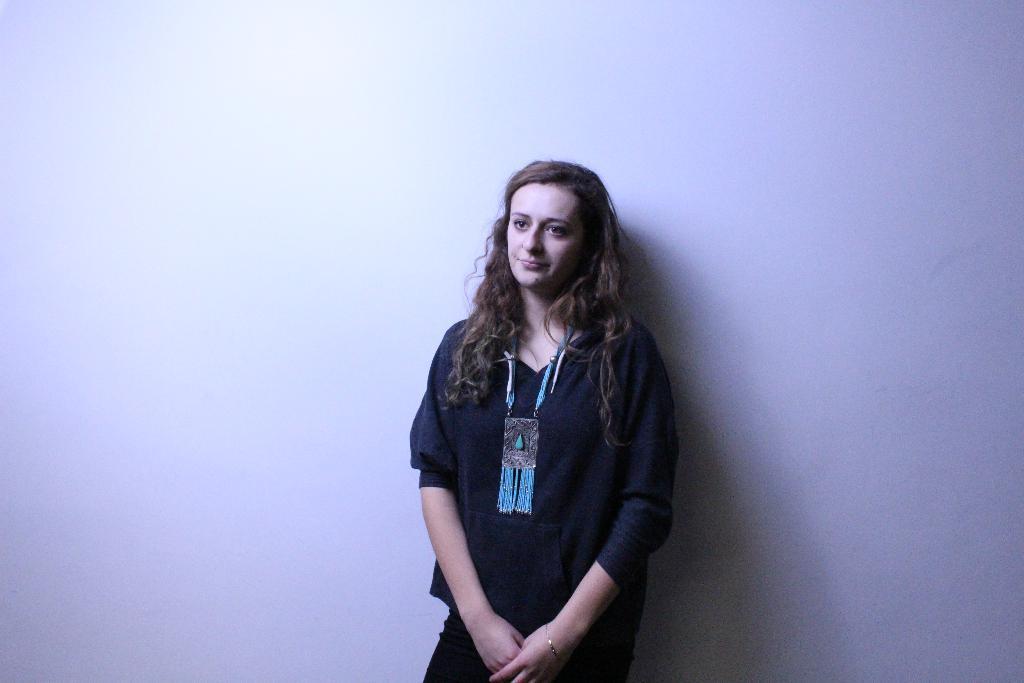Describe this image in one or two sentences. In this picture we can observe a woman standing wearing black color dress. She is smiling. We can observe a white color wall in the background. 